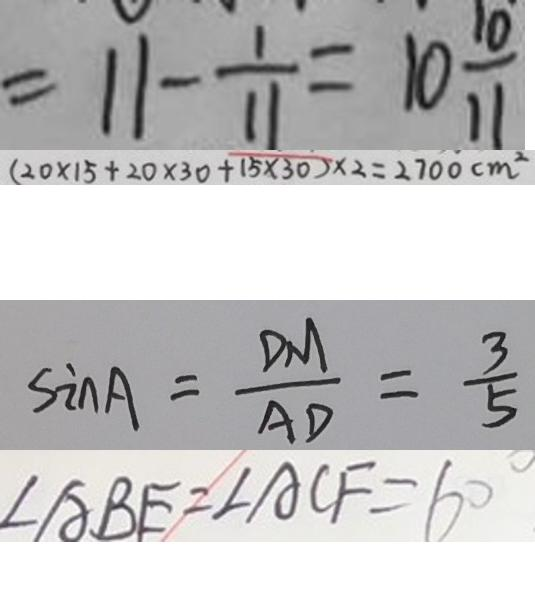Convert formula to latex. <formula><loc_0><loc_0><loc_500><loc_500>= 1 1 - \frac { 1 } { 1 1 } = 1 0 \frac { 1 0 } { 1 1 } 
 ( 2 0 \times 1 5 + 2 0 \times 3 0 + 1 5 \times 3 0 ) \times 2 = 2 7 0 0 c m ^ { 2 } 
 \sin A = \frac { D M } { A D } = \frac { 3 } { 5 } 
 \angle A B E = \angle A C F = 6 0 ^ { \circ }</formula> 